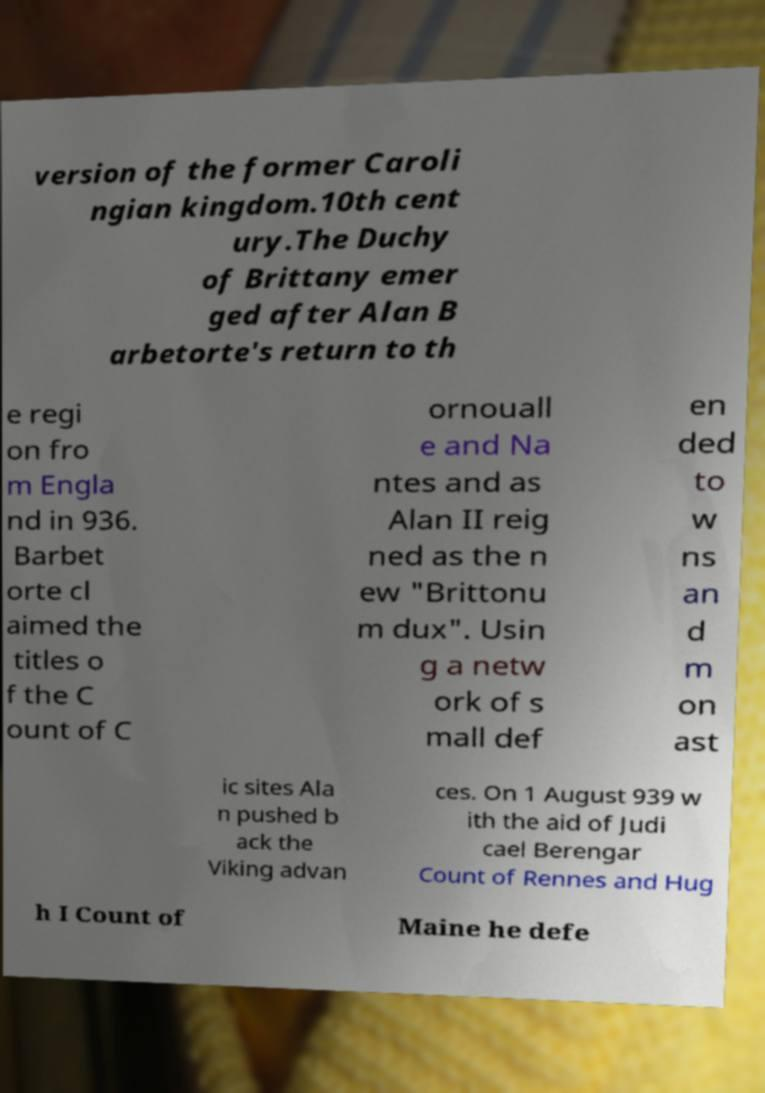Please identify and transcribe the text found in this image. version of the former Caroli ngian kingdom.10th cent ury.The Duchy of Brittany emer ged after Alan B arbetorte's return to th e regi on fro m Engla nd in 936. Barbet orte cl aimed the titles o f the C ount of C ornouall e and Na ntes and as Alan II reig ned as the n ew "Brittonu m dux". Usin g a netw ork of s mall def en ded to w ns an d m on ast ic sites Ala n pushed b ack the Viking advan ces. On 1 August 939 w ith the aid of Judi cael Berengar Count of Rennes and Hug h I Count of Maine he defe 